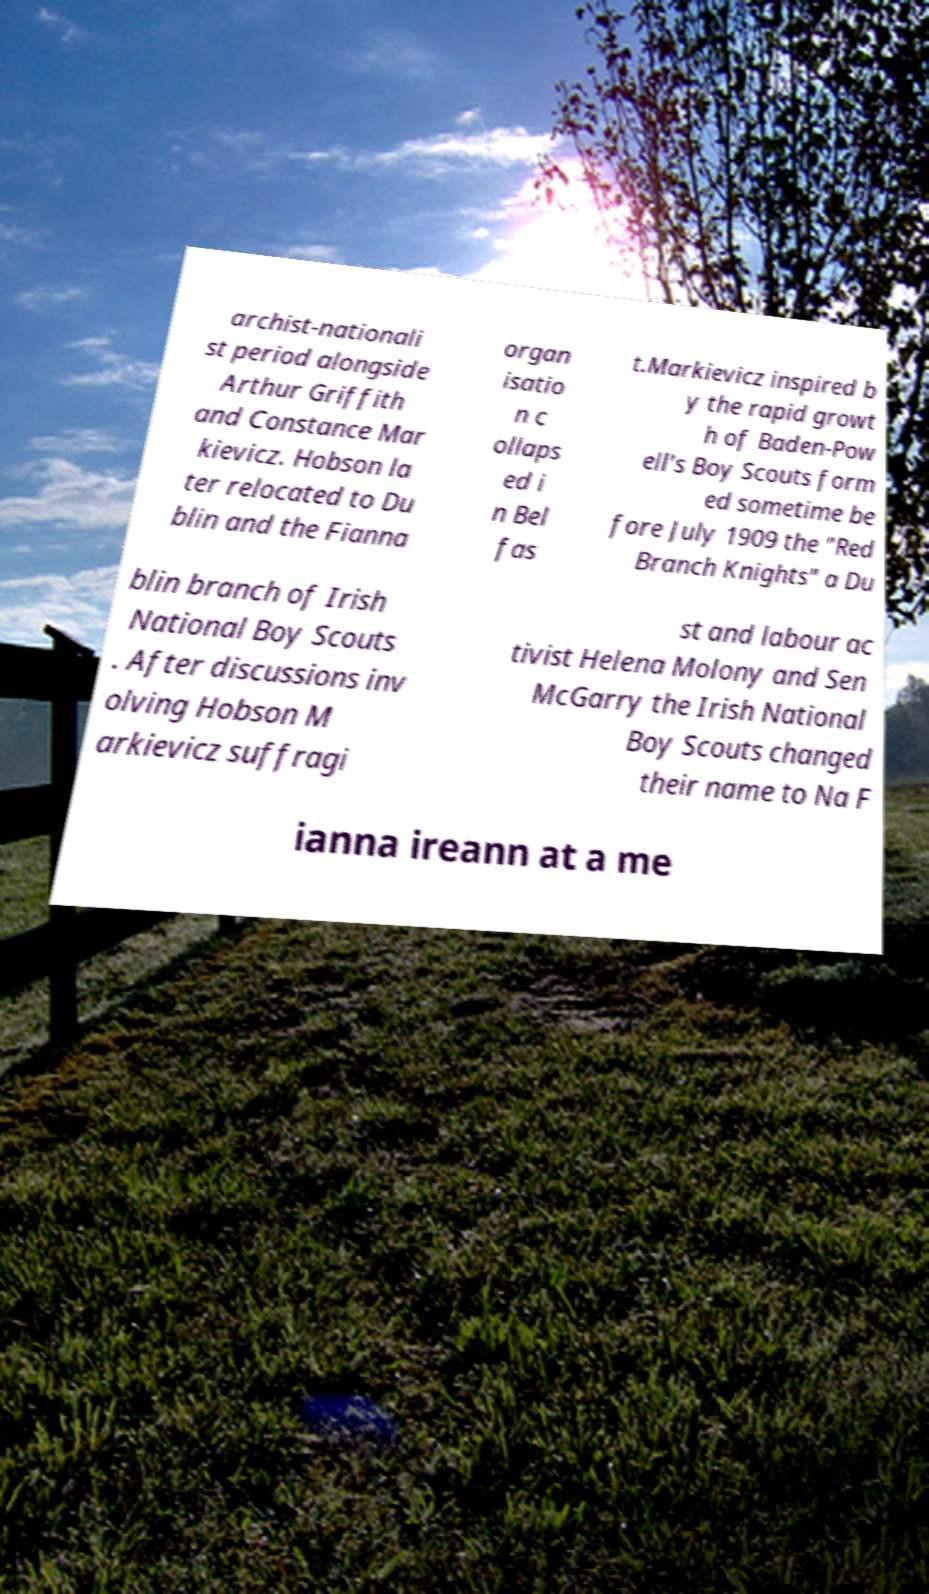Could you extract and type out the text from this image? archist-nationali st period alongside Arthur Griffith and Constance Mar kievicz. Hobson la ter relocated to Du blin and the Fianna organ isatio n c ollaps ed i n Bel fas t.Markievicz inspired b y the rapid growt h of Baden-Pow ell's Boy Scouts form ed sometime be fore July 1909 the "Red Branch Knights" a Du blin branch of Irish National Boy Scouts . After discussions inv olving Hobson M arkievicz suffragi st and labour ac tivist Helena Molony and Sen McGarry the Irish National Boy Scouts changed their name to Na F ianna ireann at a me 